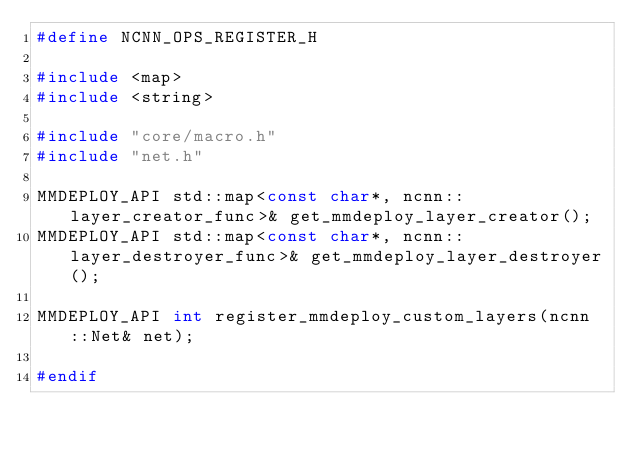<code> <loc_0><loc_0><loc_500><loc_500><_C_>#define NCNN_OPS_REGISTER_H

#include <map>
#include <string>

#include "core/macro.h"
#include "net.h"

MMDEPLOY_API std::map<const char*, ncnn::layer_creator_func>& get_mmdeploy_layer_creator();
MMDEPLOY_API std::map<const char*, ncnn::layer_destroyer_func>& get_mmdeploy_layer_destroyer();

MMDEPLOY_API int register_mmdeploy_custom_layers(ncnn::Net& net);

#endif
</code> 